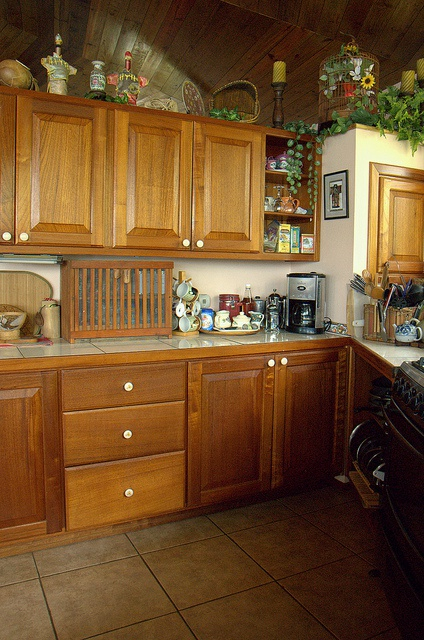Describe the objects in this image and their specific colors. I can see oven in maroon, black, gray, and darkgreen tones, potted plant in maroon, olive, black, and gray tones, potted plant in maroon, darkgreen, black, and olive tones, potted plant in maroon, darkgreen, and black tones, and cup in maroon, darkgray, tan, beige, and khaki tones in this image. 